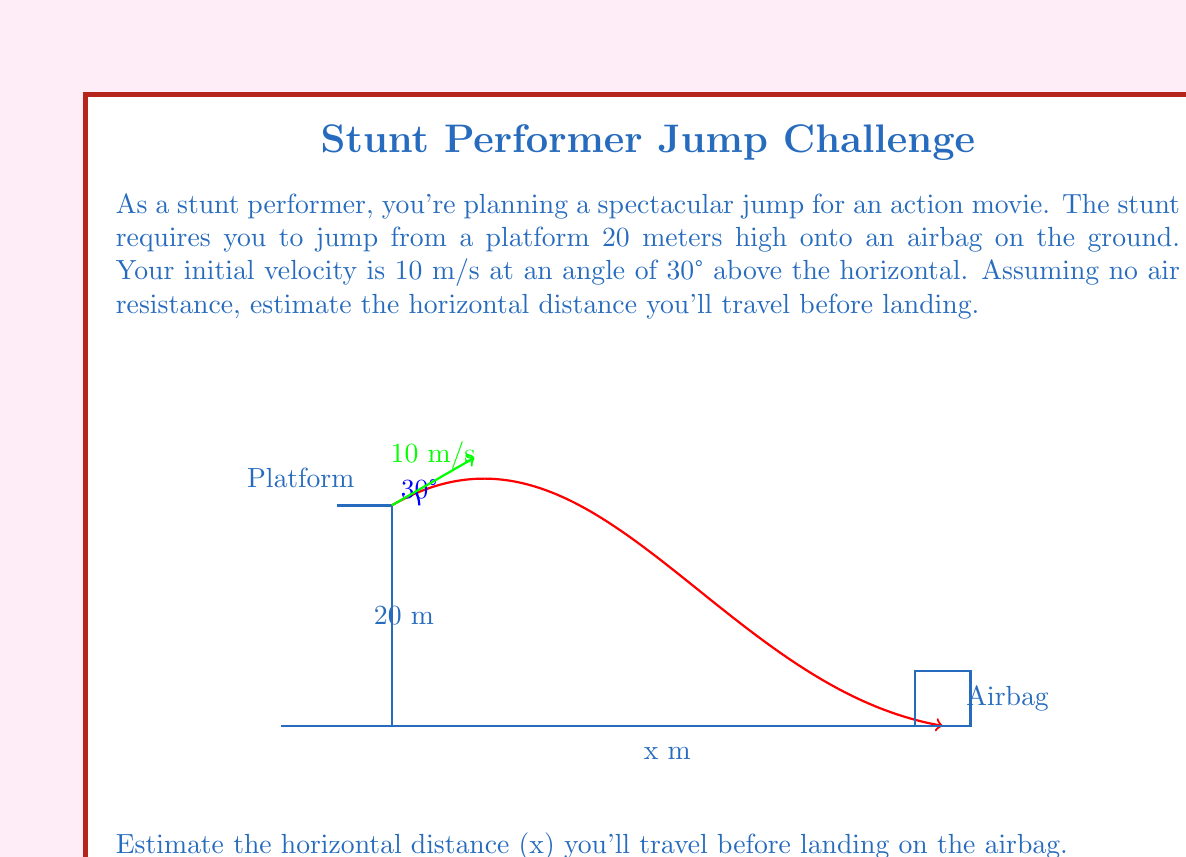Teach me how to tackle this problem. To solve this problem, we'll use the equations of motion for projectile motion. Let's break it down step-by-step:

1) First, let's identify the known variables:
   - Initial height (h) = 20 m
   - Initial velocity (v₀) = 10 m/s
   - Angle of projection (θ) = 30°
   - Acceleration due to gravity (g) = 9.8 m/s²

2) We need to find the time of flight and the horizontal distance traveled.

3) The horizontal and vertical components of the initial velocity are:
   $v_{0x} = v_0 \cos{\theta} = 10 \cos{30°} = 8.66$ m/s
   $v_{0y} = v_0 \sin{\theta} = 10 \sin{30°} = 5$ m/s

4) To find the time of flight, we use the equation:
   $h = v_{0y}t - \frac{1}{2}gt^2$

   $20 = 5t - \frac{1}{2}(9.8)t^2$

   $4.9t^2 - 5t - 20 = 0$

5) Solving this quadratic equation:
   $t = \frac{5 \pm \sqrt{25 + 4(4.9)(20)}}{2(4.9)} = \frac{5 \pm \sqrt{421}}{9.8}$

   We take the positive root: $t = \frac{5 + \sqrt{421}}{9.8} \approx 2.54$ seconds

6) Now, we can calculate the horizontal distance:
   $x = v_{0x}t = 8.66 * 2.54 \approx 22$ meters

Therefore, you'll travel approximately 22 meters horizontally before landing on the airbag.
Answer: 22 meters 